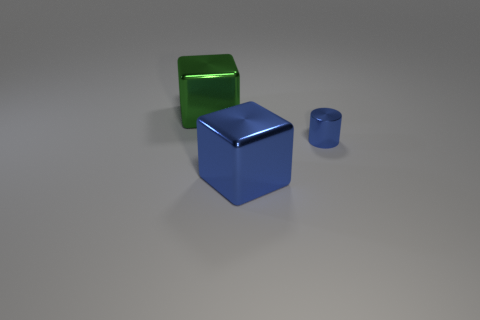What number of big blue metallic cubes are to the right of the thing in front of the metallic cylinder?
Provide a short and direct response. 0. What number of other things are the same material as the large blue object?
Your response must be concise. 2. What shape is the metal thing in front of the blue thing that is right of the big blue block?
Offer a very short reply. Cube. What size is the cube on the right side of the large green metallic cube?
Offer a terse response. Large. Are the small blue cylinder and the big green object made of the same material?
Offer a very short reply. Yes. There is a tiny thing that is made of the same material as the big green block; what is its shape?
Make the answer very short. Cylinder. Is there any other thing that is the same color as the tiny cylinder?
Give a very brief answer. Yes. There is a big metal object in front of the blue metallic cylinder; what color is it?
Your answer should be very brief. Blue. There is a large metallic object that is on the right side of the green object; is its color the same as the cylinder?
Provide a short and direct response. Yes. There is a blue thing that is the same shape as the green metal object; what is its material?
Keep it short and to the point. Metal. 